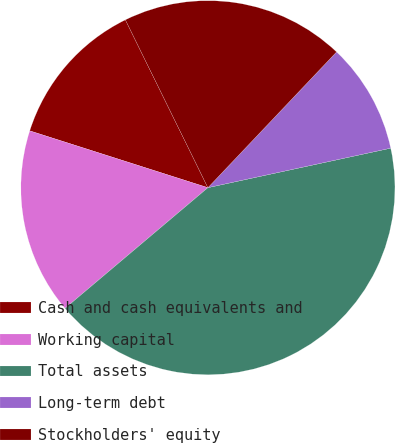<chart> <loc_0><loc_0><loc_500><loc_500><pie_chart><fcel>Cash and cash equivalents and<fcel>Working capital<fcel>Total assets<fcel>Long-term debt<fcel>Stockholders' equity<nl><fcel>12.81%<fcel>16.08%<fcel>42.23%<fcel>9.54%<fcel>19.35%<nl></chart> 